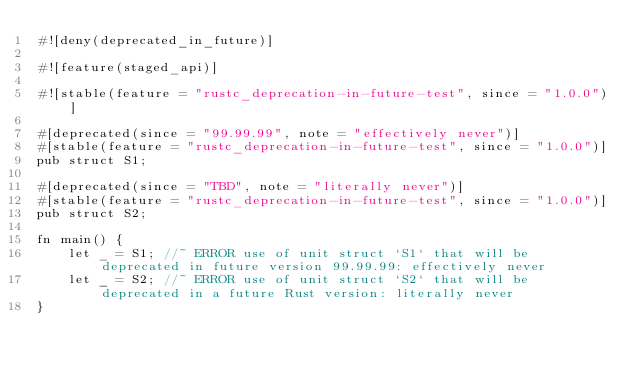<code> <loc_0><loc_0><loc_500><loc_500><_Rust_>#![deny(deprecated_in_future)]

#![feature(staged_api)]

#![stable(feature = "rustc_deprecation-in-future-test", since = "1.0.0")]

#[deprecated(since = "99.99.99", note = "effectively never")]
#[stable(feature = "rustc_deprecation-in-future-test", since = "1.0.0")]
pub struct S1;

#[deprecated(since = "TBD", note = "literally never")]
#[stable(feature = "rustc_deprecation-in-future-test", since = "1.0.0")]
pub struct S2;

fn main() {
    let _ = S1; //~ ERROR use of unit struct `S1` that will be deprecated in future version 99.99.99: effectively never
    let _ = S2; //~ ERROR use of unit struct `S2` that will be deprecated in a future Rust version: literally never
}
</code> 